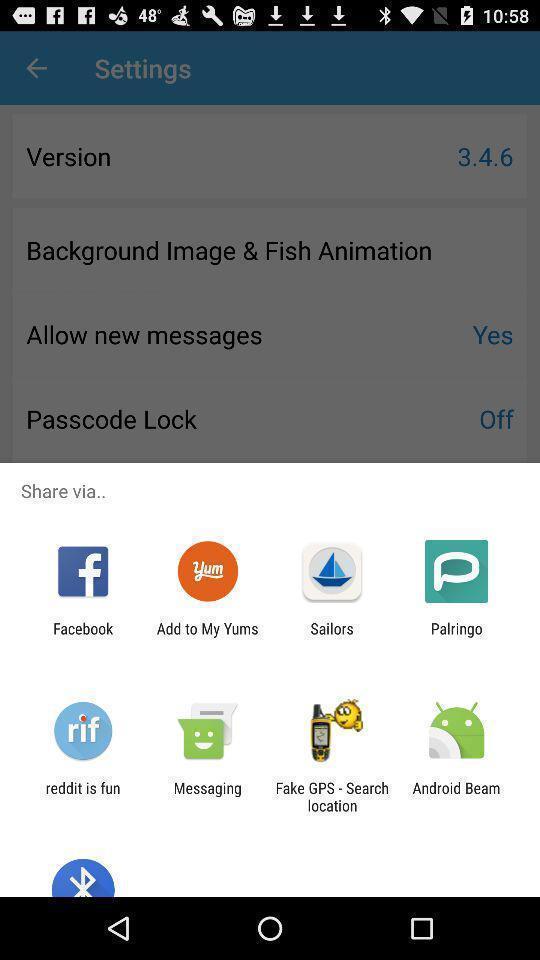Give me a narrative description of this picture. Share with options page of a social app. 